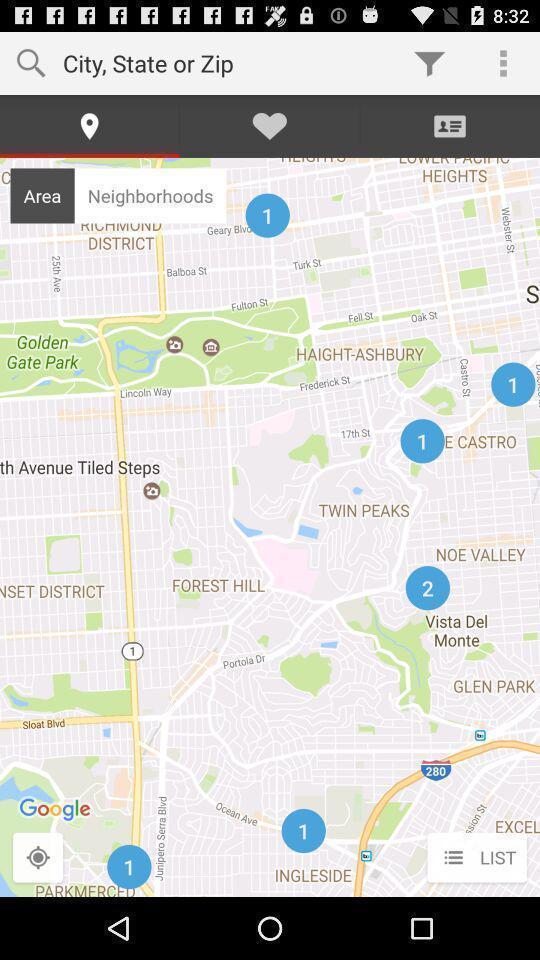What is the overall content of this screenshot? Screen displaying a map view with multiple control options. 